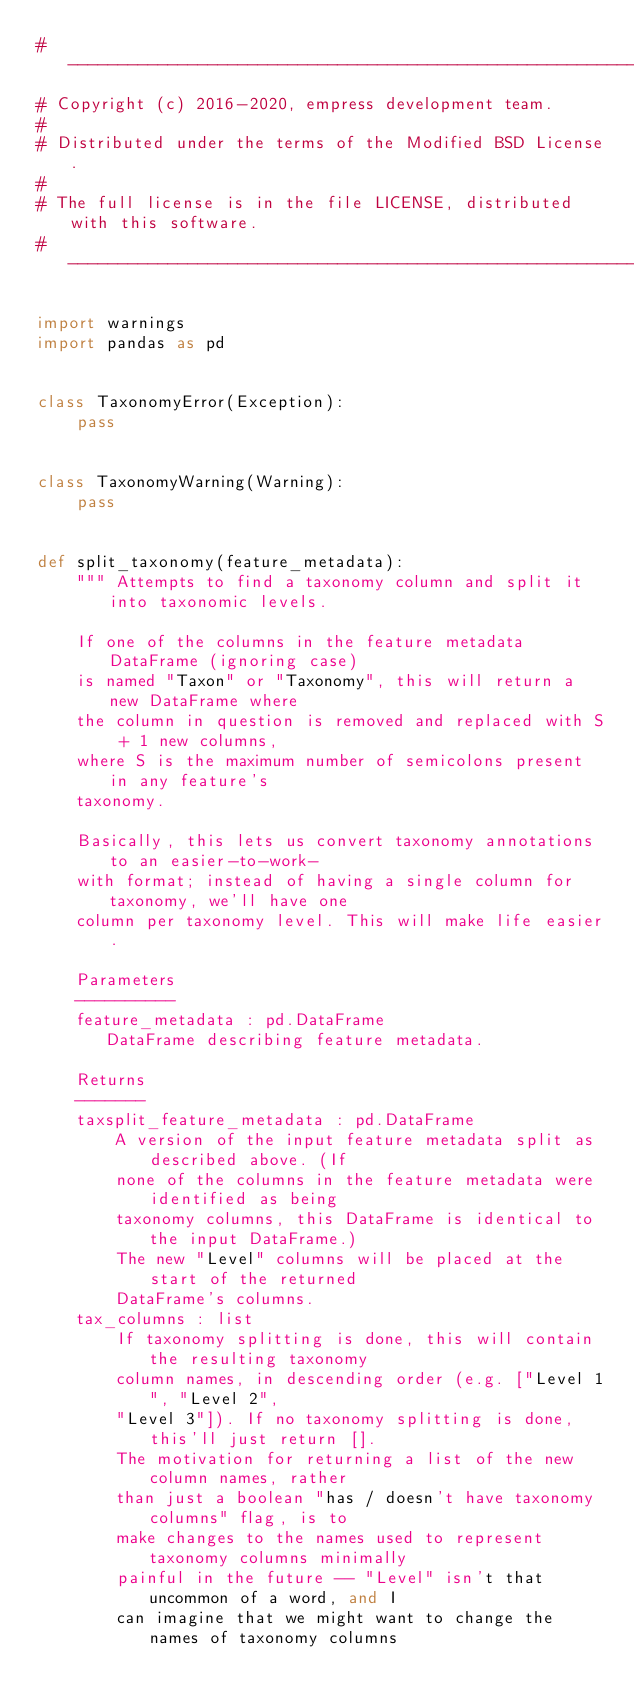<code> <loc_0><loc_0><loc_500><loc_500><_Python_># ----------------------------------------------------------------------------
# Copyright (c) 2016-2020, empress development team.
#
# Distributed under the terms of the Modified BSD License.
#
# The full license is in the file LICENSE, distributed with this software.
# ----------------------------------------------------------------------------

import warnings
import pandas as pd


class TaxonomyError(Exception):
    pass


class TaxonomyWarning(Warning):
    pass


def split_taxonomy(feature_metadata):
    """ Attempts to find a taxonomy column and split it into taxonomic levels.

    If one of the columns in the feature metadata DataFrame (ignoring case)
    is named "Taxon" or "Taxonomy", this will return a new DataFrame where
    the column in question is removed and replaced with S + 1 new columns,
    where S is the maximum number of semicolons present in any feature's
    taxonomy.

    Basically, this lets us convert taxonomy annotations to an easier-to-work-
    with format; instead of having a single column for taxonomy, we'll have one
    column per taxonomy level. This will make life easier.

    Parameters
    ----------
    feature_metadata : pd.DataFrame
       DataFrame describing feature metadata.

    Returns
    -------
    taxsplit_feature_metadata : pd.DataFrame
        A version of the input feature metadata split as described above. (If
        none of the columns in the feature metadata were identified as being
        taxonomy columns, this DataFrame is identical to the input DataFrame.)
        The new "Level" columns will be placed at the start of the returned
        DataFrame's columns.
    tax_columns : list
        If taxonomy splitting is done, this will contain the resulting taxonomy
        column names, in descending order (e.g. ["Level 1", "Level 2",
        "Level 3"]). If no taxonomy splitting is done, this'll just return [].
        The motivation for returning a list of the new column names, rather
        than just a boolean "has / doesn't have taxonomy columns" flag, is to
        make changes to the names used to represent taxonomy columns minimally
        painful in the future -- "Level" isn't that uncommon of a word, and I
        can imagine that we might want to change the names of taxonomy columns</code> 